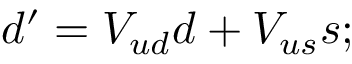Convert formula to latex. <formula><loc_0><loc_0><loc_500><loc_500>d ^ { \prime } = V _ { u d } d + V _ { u s } s ;</formula> 